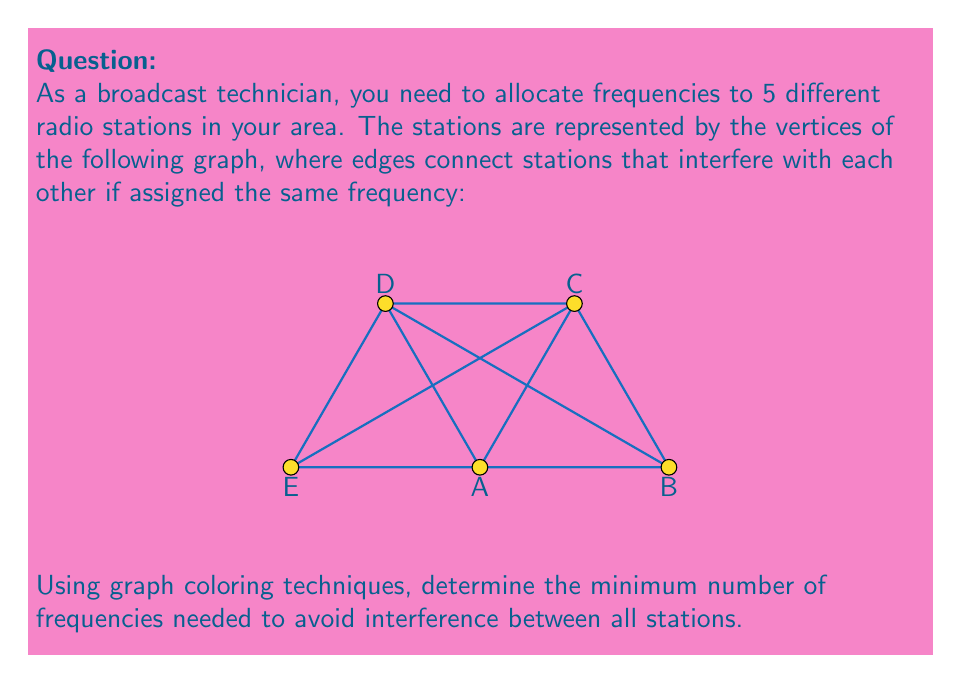Help me with this question. To solve this problem, we'll use graph coloring techniques. Each color represents a unique frequency, and adjacent vertices (connected by an edge) must have different colors.

Step 1: Analyze the graph structure
The graph is a complete graph K5 (a pentagon with all diagonals), where every vertex is connected to every other vertex.

Step 2: Apply the chromatic number theorem
For a complete graph Kn, the chromatic number (minimum number of colors needed) is always n. In this case, n = 5.

Step 3: Verify that no fewer colors are possible
- If we try to use 4 colors, we would have to assign the same color to at least two vertices.
- However, every pair of vertices is connected by an edge, so this would result in interference.

Step 4: Assign colors (frequencies)
We can assign 5 different colors to the 5 vertices:
A: Color 1
B: Color 2
C: Color 3
D: Color 4
E: Color 5

This coloring ensures that no two adjacent vertices have the same color, thus avoiding interference between all stations.
Answer: 5 frequencies 